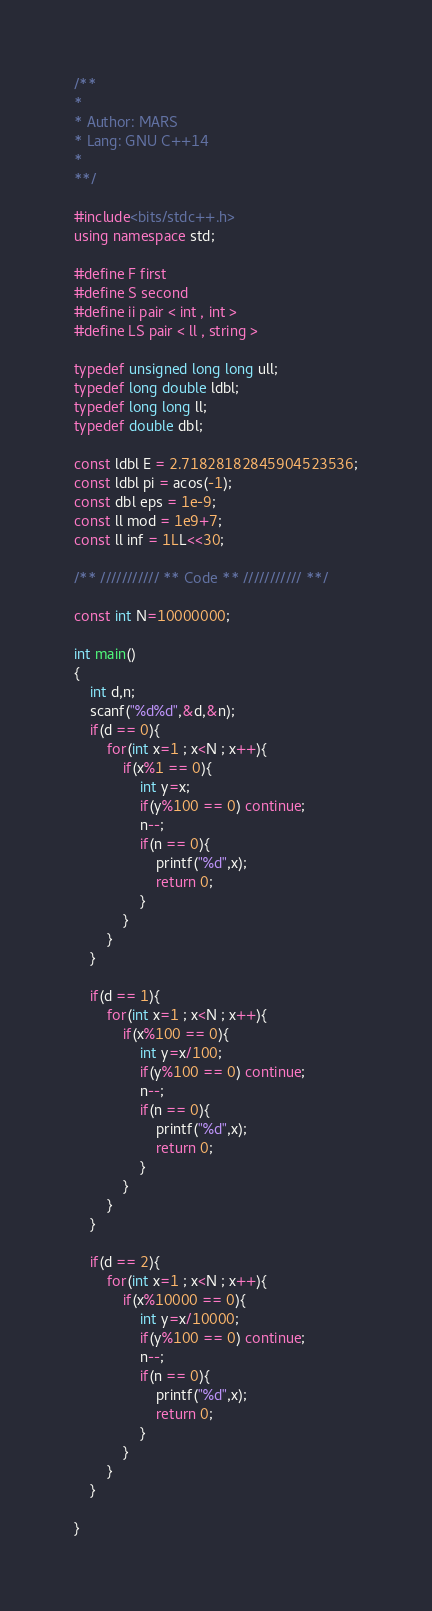Convert code to text. <code><loc_0><loc_0><loc_500><loc_500><_C++_>/**
*
* Author: MARS
* Lang: GNU C++14
*
**/

#include<bits/stdc++.h>
using namespace std;

#define F first
#define S second
#define ii pair < int , int >
#define LS pair < ll , string >

typedef unsigned long long ull;
typedef long double ldbl;
typedef long long ll;
typedef double dbl;

const ldbl E = 2.71828182845904523536;
const ldbl pi = acos(-1);
const dbl eps = 1e-9;
const ll mod = 1e9+7;
const ll inf = 1LL<<30;

/** /////////// ** Code ** /////////// **/

const int N=10000000;

int main()
{
    int d,n;
    scanf("%d%d",&d,&n);
    if(d == 0){
        for(int x=1 ; x<N ; x++){
            if(x%1 == 0){
                int y=x;
                if(y%100 == 0) continue;
                n--;
                if(n == 0){
                    printf("%d",x);
                    return 0;
                }
            }
        }
    }

    if(d == 1){
        for(int x=1 ; x<N ; x++){
            if(x%100 == 0){
                int y=x/100;
                if(y%100 == 0) continue;
                n--;
                if(n == 0){
                    printf("%d",x);
                    return 0;
                }
            }
        }
    }

    if(d == 2){
        for(int x=1 ; x<N ; x++){
            if(x%10000 == 0){
                int y=x/10000;
                if(y%100 == 0) continue;
                n--;
                if(n == 0){
                    printf("%d",x);
                    return 0;
                }
            }
        }
    }

}
</code> 